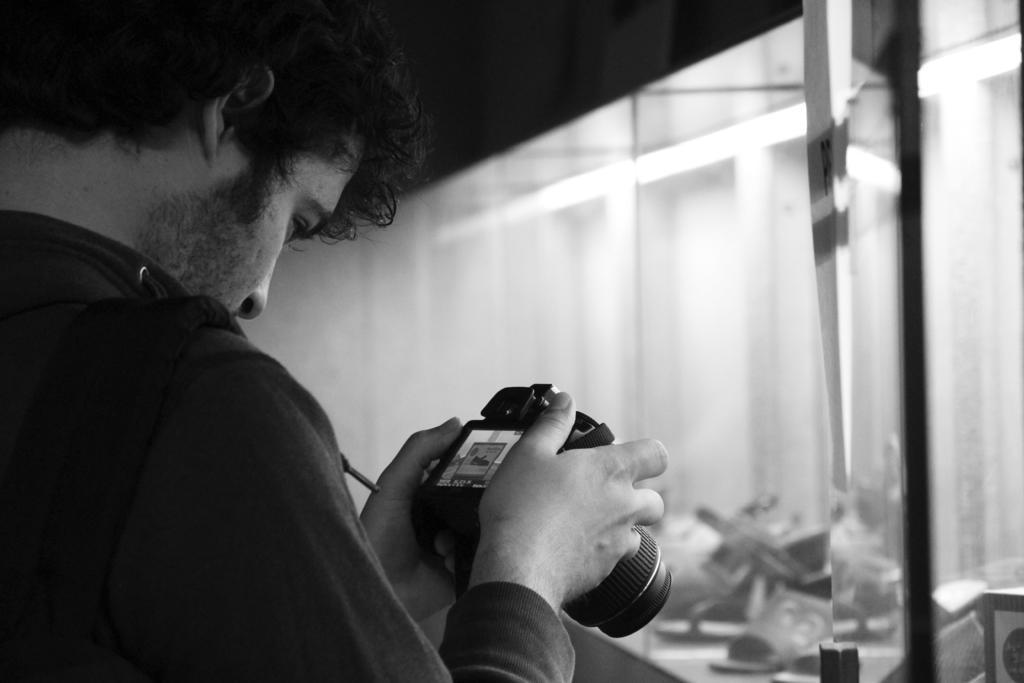Could you give a brief overview of what you see in this image? In the image I can see a man on the left side and he is holding a camera in his hands. I can see the glass window on the right side. I can see the footwear at the bottom of the image. 